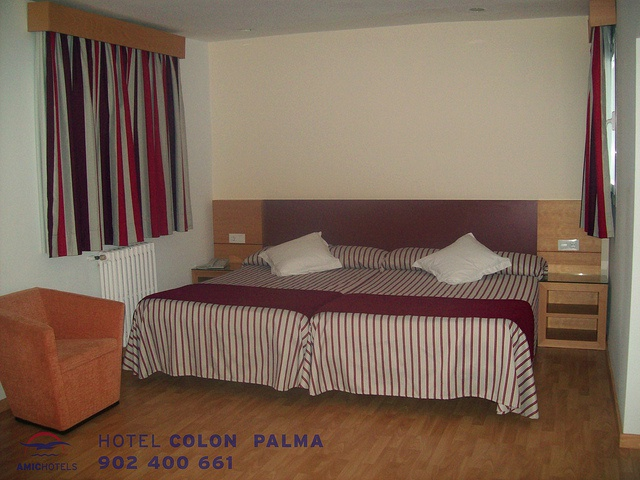Describe the objects in this image and their specific colors. I can see bed in gray, darkgray, and maroon tones and chair in gray, maroon, and brown tones in this image. 